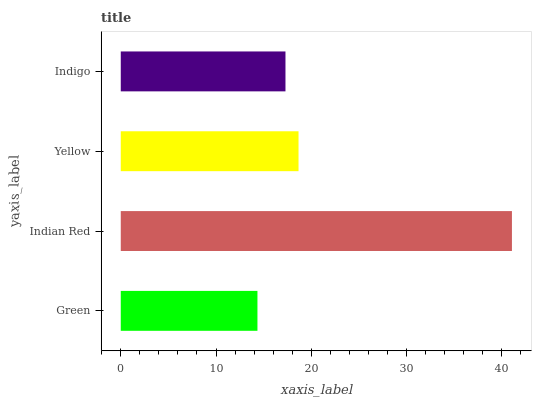Is Green the minimum?
Answer yes or no. Yes. Is Indian Red the maximum?
Answer yes or no. Yes. Is Yellow the minimum?
Answer yes or no. No. Is Yellow the maximum?
Answer yes or no. No. Is Indian Red greater than Yellow?
Answer yes or no. Yes. Is Yellow less than Indian Red?
Answer yes or no. Yes. Is Yellow greater than Indian Red?
Answer yes or no. No. Is Indian Red less than Yellow?
Answer yes or no. No. Is Yellow the high median?
Answer yes or no. Yes. Is Indigo the low median?
Answer yes or no. Yes. Is Indigo the high median?
Answer yes or no. No. Is Indian Red the low median?
Answer yes or no. No. 